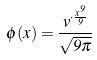<formula> <loc_0><loc_0><loc_500><loc_500>\phi ( x ) = \frac { v ^ { \cdot \frac { x ^ { 9 } } { 9 } } } { \sqrt { 9 \pi } }</formula> 